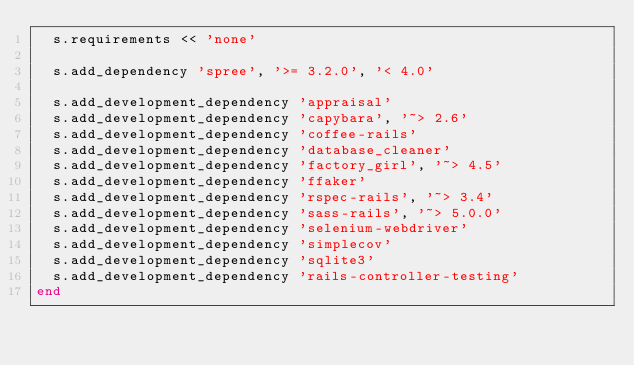Convert code to text. <code><loc_0><loc_0><loc_500><loc_500><_Ruby_>  s.requirements << 'none'

  s.add_dependency 'spree', '>= 3.2.0', '< 4.0'

  s.add_development_dependency 'appraisal'
  s.add_development_dependency 'capybara', '~> 2.6'
  s.add_development_dependency 'coffee-rails'
  s.add_development_dependency 'database_cleaner'
  s.add_development_dependency 'factory_girl', '~> 4.5'
  s.add_development_dependency 'ffaker'
  s.add_development_dependency 'rspec-rails', '~> 3.4'
  s.add_development_dependency 'sass-rails', '~> 5.0.0'
  s.add_development_dependency 'selenium-webdriver'
  s.add_development_dependency 'simplecov'
  s.add_development_dependency 'sqlite3'
  s.add_development_dependency 'rails-controller-testing'
end
</code> 